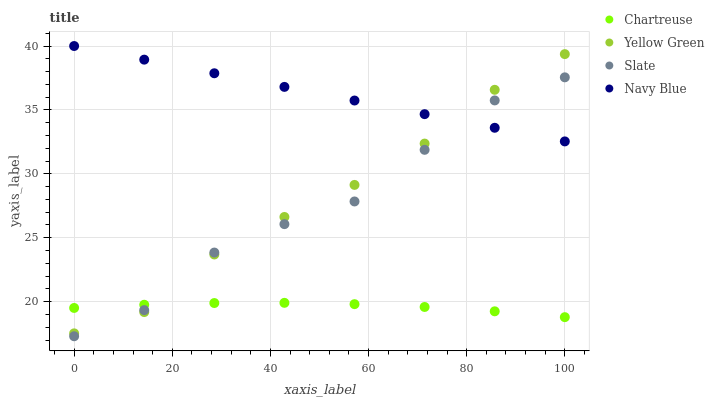Does Chartreuse have the minimum area under the curve?
Answer yes or no. Yes. Does Navy Blue have the maximum area under the curve?
Answer yes or no. Yes. Does Slate have the minimum area under the curve?
Answer yes or no. No. Does Slate have the maximum area under the curve?
Answer yes or no. No. Is Navy Blue the smoothest?
Answer yes or no. Yes. Is Slate the roughest?
Answer yes or no. Yes. Is Chartreuse the smoothest?
Answer yes or no. No. Is Chartreuse the roughest?
Answer yes or no. No. Does Slate have the lowest value?
Answer yes or no. Yes. Does Chartreuse have the lowest value?
Answer yes or no. No. Does Navy Blue have the highest value?
Answer yes or no. Yes. Does Slate have the highest value?
Answer yes or no. No. Is Chartreuse less than Navy Blue?
Answer yes or no. Yes. Is Navy Blue greater than Chartreuse?
Answer yes or no. Yes. Does Yellow Green intersect Chartreuse?
Answer yes or no. Yes. Is Yellow Green less than Chartreuse?
Answer yes or no. No. Is Yellow Green greater than Chartreuse?
Answer yes or no. No. Does Chartreuse intersect Navy Blue?
Answer yes or no. No. 